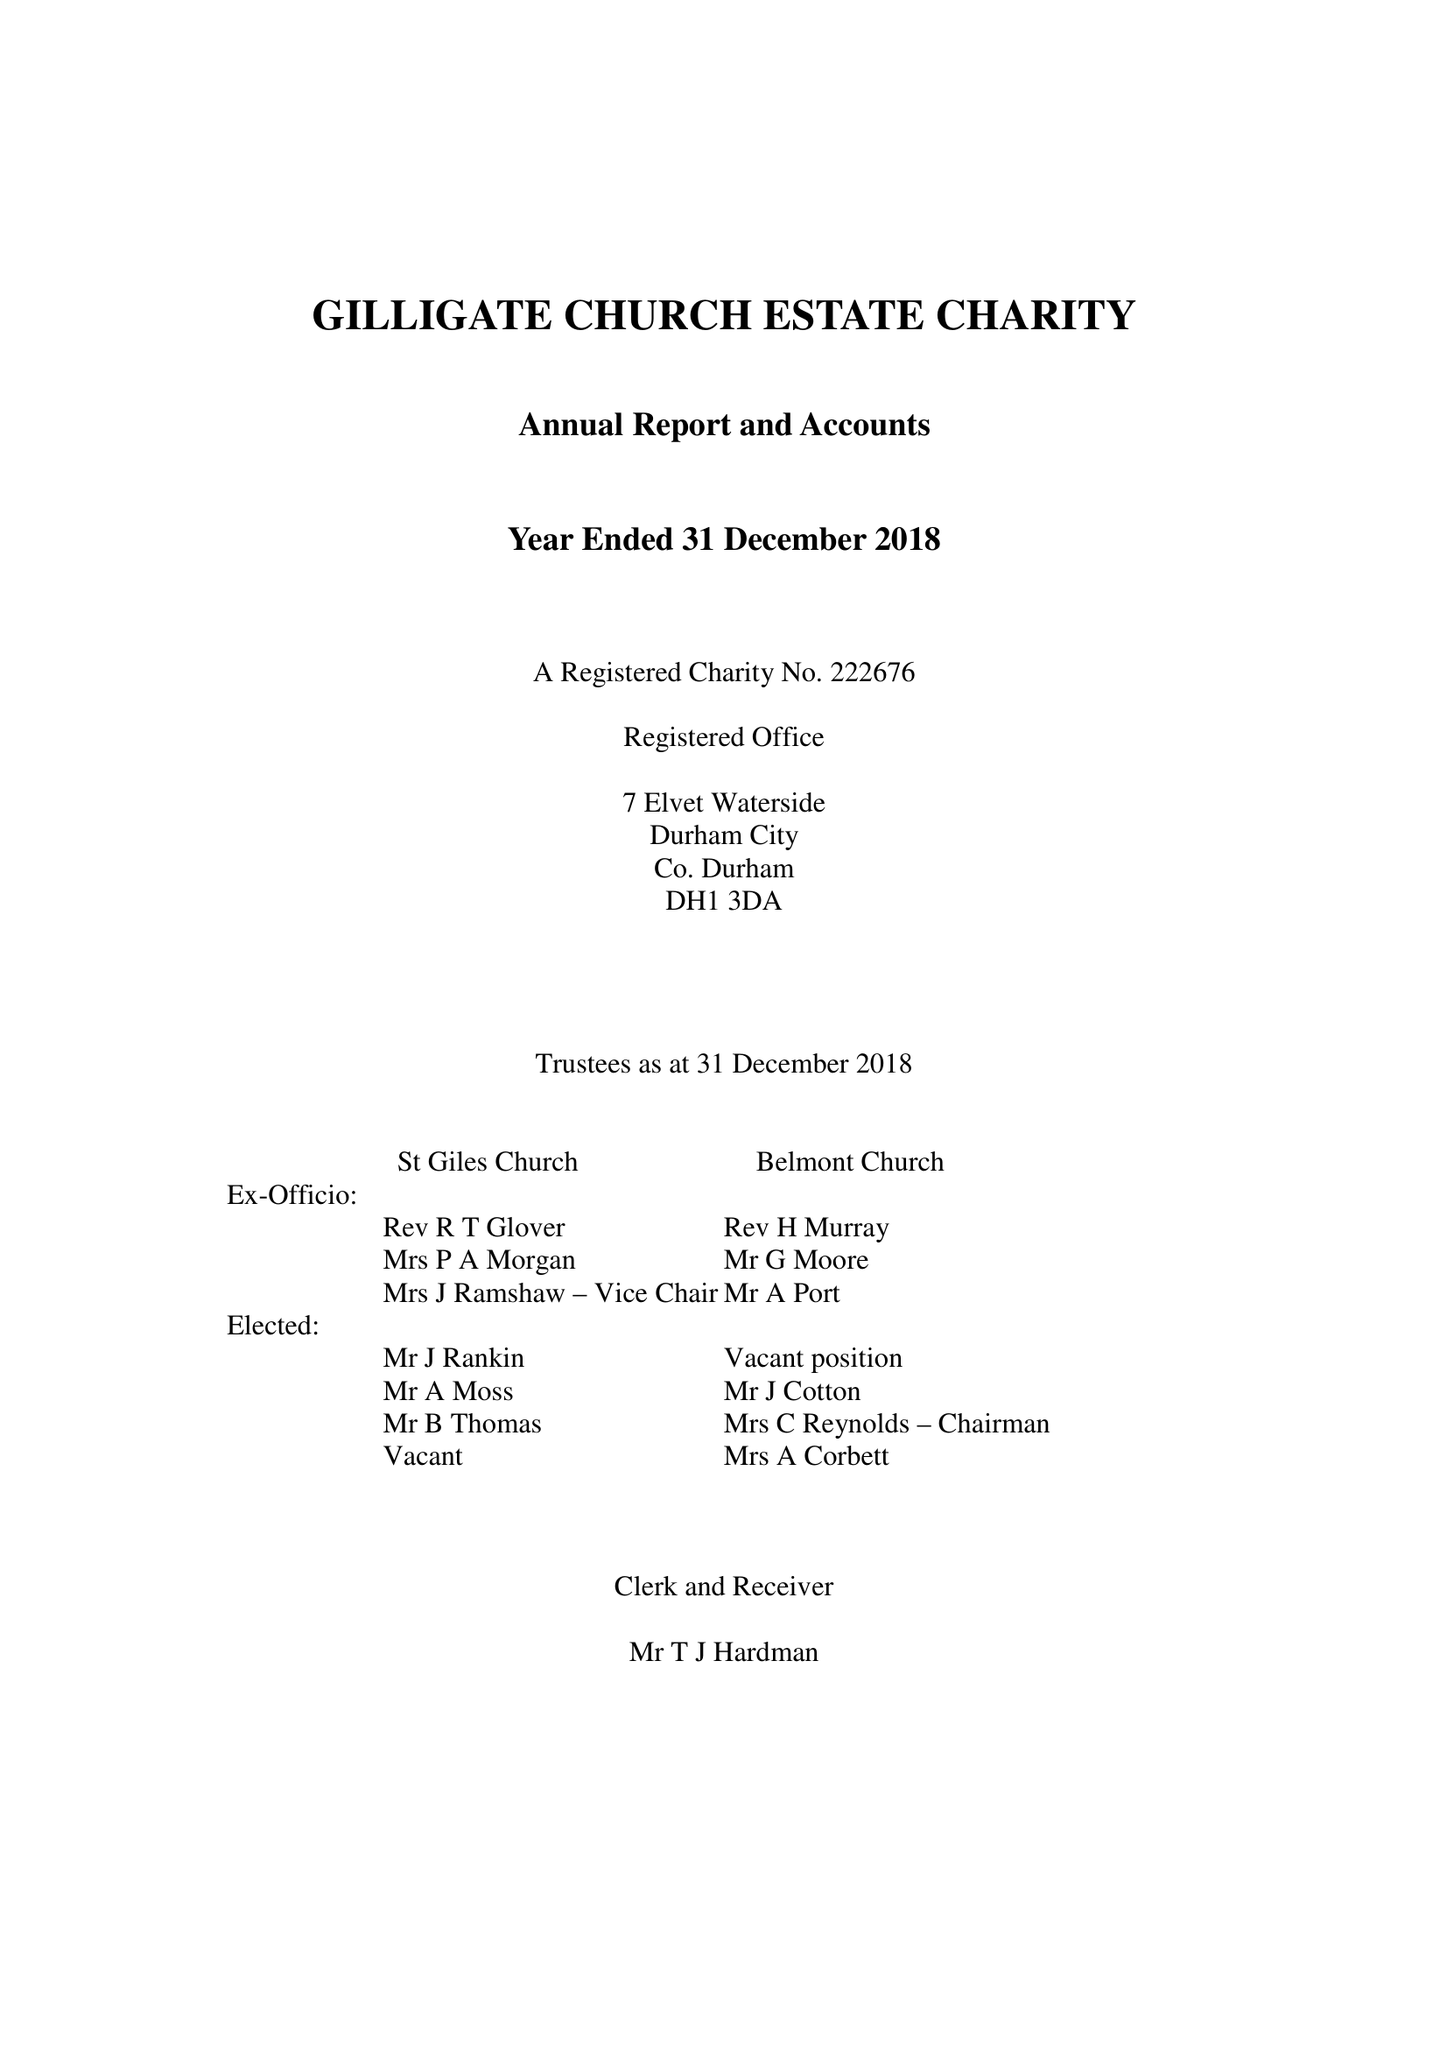What is the value for the address__postcode?
Answer the question using a single word or phrase. DH1 3DA 